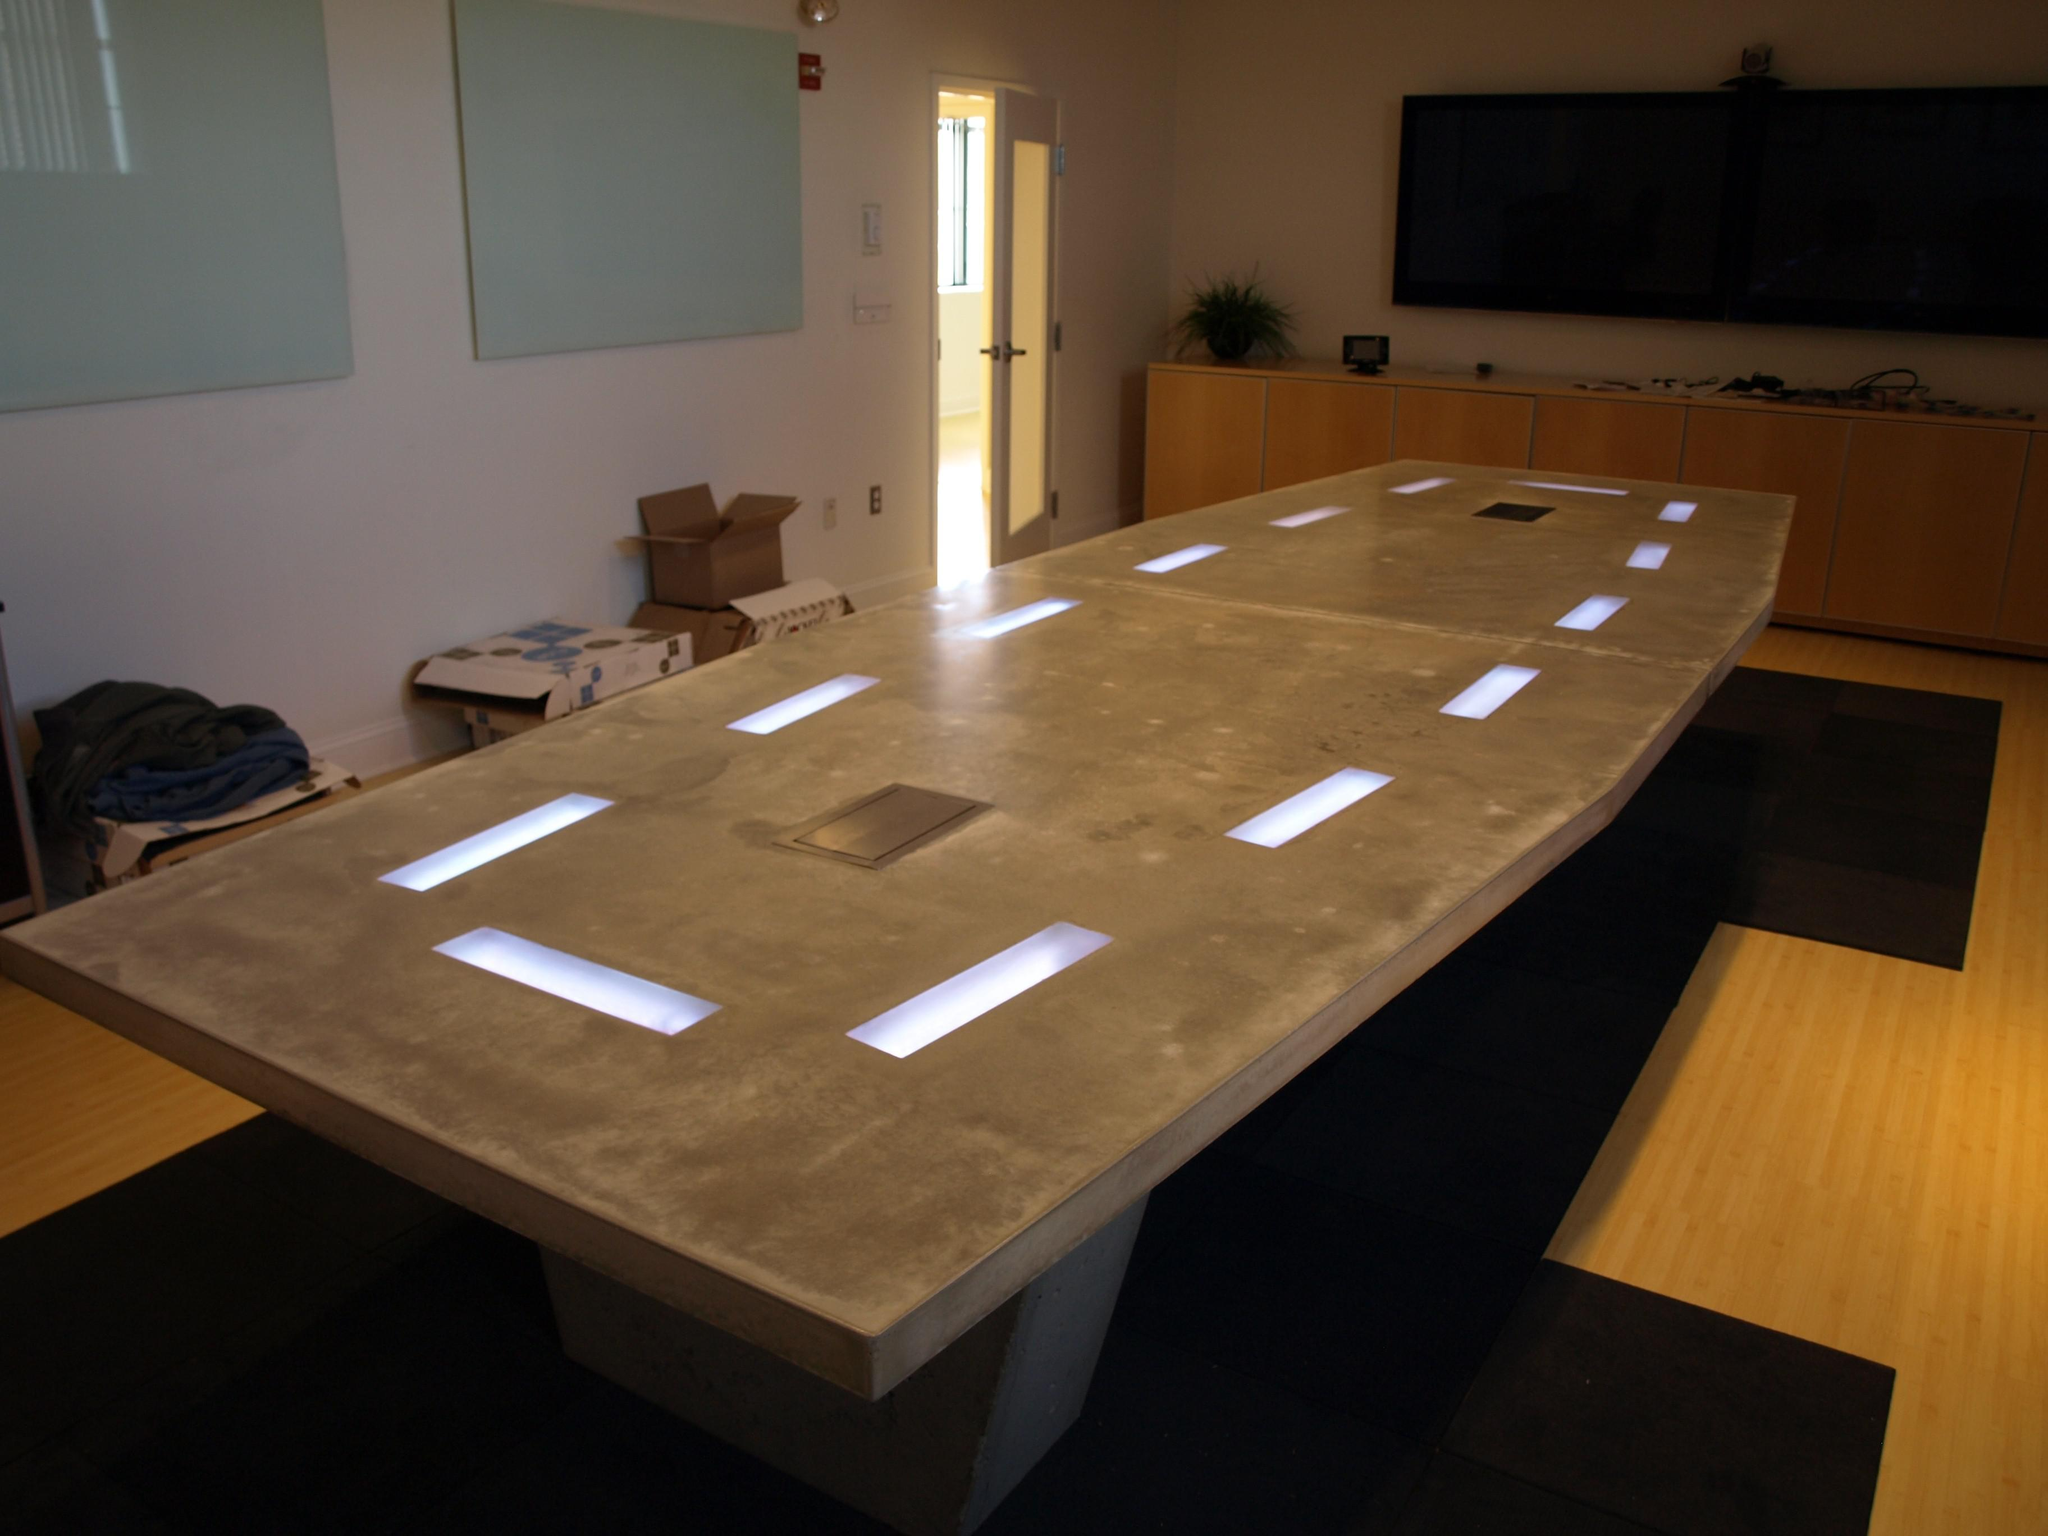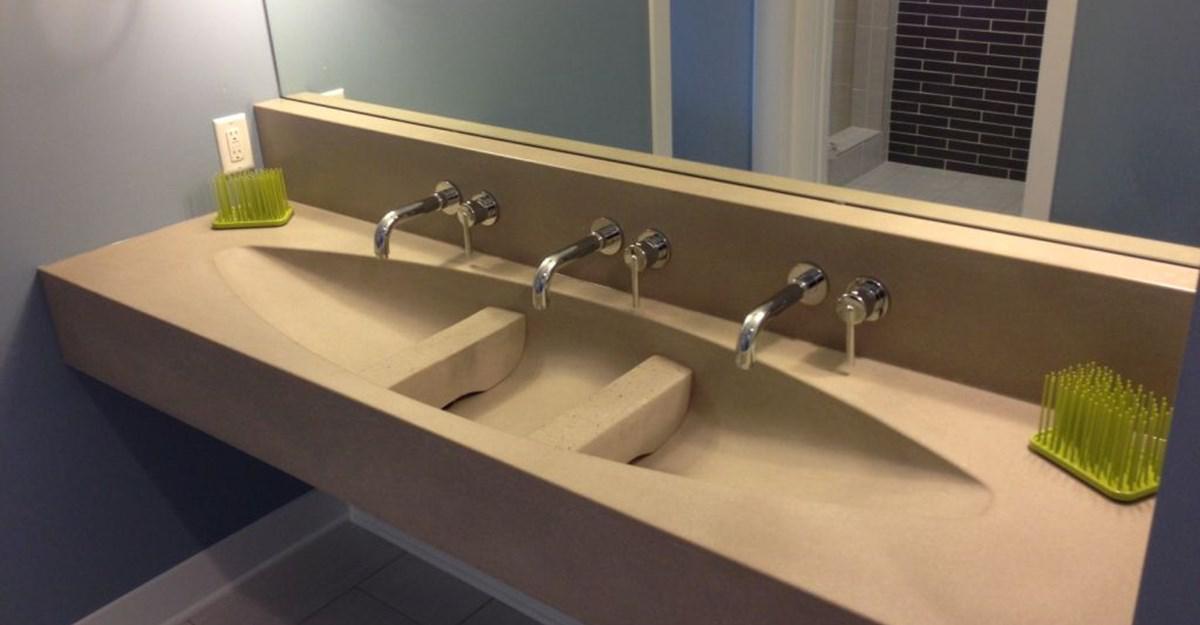The first image is the image on the left, the second image is the image on the right. Assess this claim about the two images: "There are three faucets.". Correct or not? Answer yes or no. Yes. The first image is the image on the left, the second image is the image on the right. For the images displayed, is the sentence "Each image shows a grey/silver vanity with only one sink." factually correct? Answer yes or no. No. 